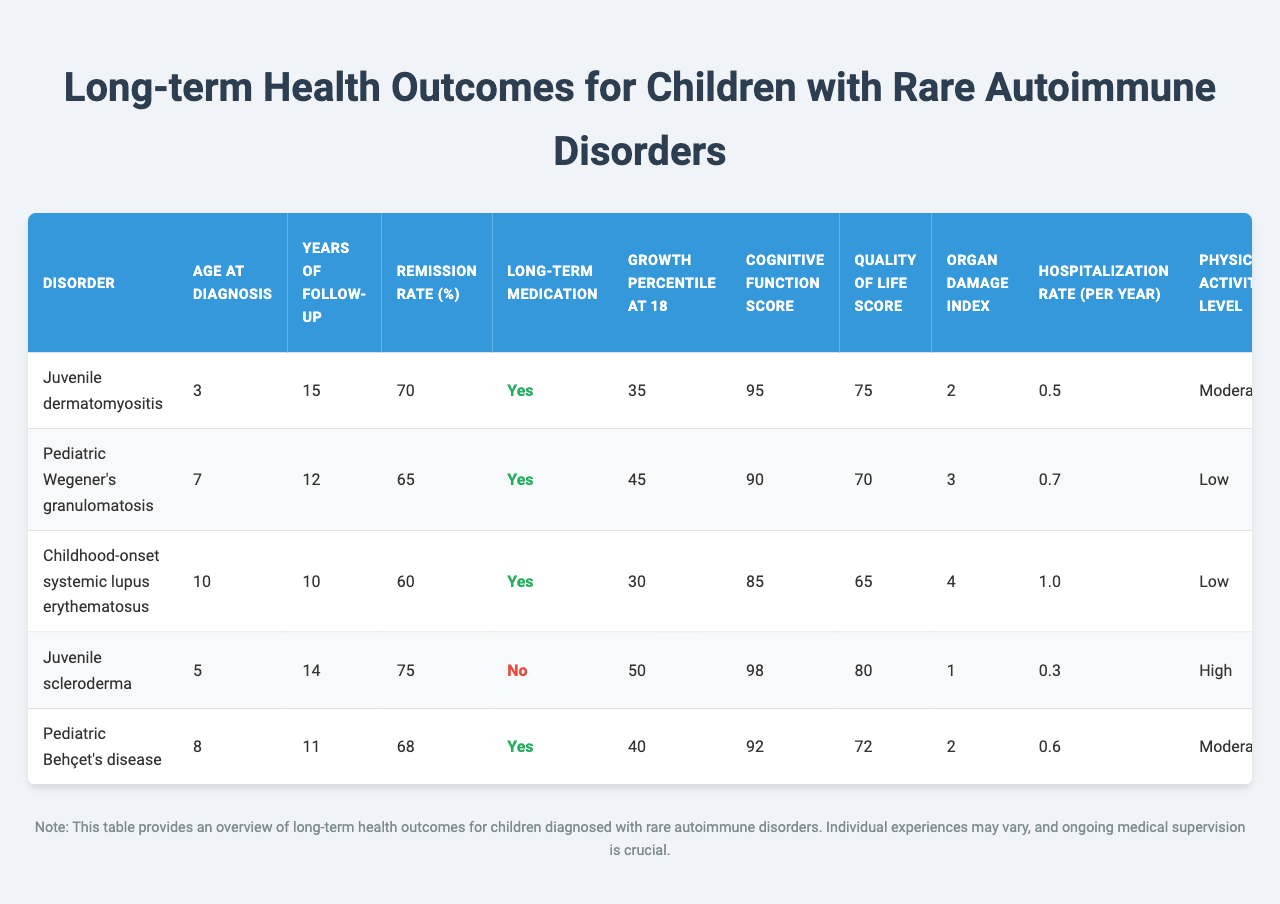What is the highest remission rate percentage among the disorders listed? The remission rate percentages for the different disorders are: 70%, 65%, 60%, 75%, and 68%. The highest value is 75%.
Answer: 75% Which disorder has the youngest age at diagnosis? The ages at diagnosis for each disorder are: 3, 7, 10, 5, and 8 years. The youngest age is 3 years for Juvenile dermatomyositis.
Answer: 3 years Is long-term medication required for Pediatric Behçet's disease? According to the table, long-term medication is required for Pediatric Behçet's disease, indicated by "Yes" under the Long-term Medication column.
Answer: Yes What is the average growth percentile at age 18 for the disorders listed? The growth percentiles are 35, 45, 30, 50, and 40. The average is calculated as (35 + 45 + 30 + 50 + 40) / 5 = 40.
Answer: 40 Which disorder has the lowest organ damage index? The organ damage indices are: 2, 3, 4, 1, and 2. The lowest value is 1 for Juvenile scleroderma.
Answer: 1 Are there any disorders for which psychosocial support is not needed? The table indicates that Juvenile scleroderma does not require psychosocial support, marked as "No" in that column.
Answer: Yes What can you infer about the transition to adult care success rate for Childhood-onset systemic lupus erythematosus compared to other disorders? The success rate for Childhood-onset systemic lupus erythematosus is 75%, which is lower than all others, suggesting it may face more challenges in transitioning to adult care compared to others like Juvenile scleroderma (90%).
Answer: Lower What is the difference in hospitalization rate per year between Pediatric Wegener's granulomatosis and Juvenile scleroderma? The hospitalization rates per year are 0.7 for Pediatric Wegener's granulomatosis and 0.3 for Juvenile scleroderma. The difference is 0.7 - 0.3 = 0.4.
Answer: 0.4 Do any disorders have a quality of life score below 70? The quality of life scores are 75, 70, 65, 80, and 72. Childhood-onset systemic lupus erythematosus has a score of 65, which is below 70.
Answer: Yes What percentage of children diagnosed with Juvenile scleroderma required long-term medication? The data indicates that Juvenile scleroderma does not require long-term medication, so the percentage is 0%.
Answer: 0% What is the average hospitalization rate per year for all the disorders? The hospitalization rates are 0.5, 0.7, 1.0, 0.3, and 0.6. The average is (0.5 + 0.7 + 1.0 + 0.3 + 0.6) / 5 = 0.62.
Answer: 0.62 